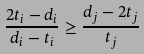<formula> <loc_0><loc_0><loc_500><loc_500>\frac { 2 t _ { i } - d _ { i } } { d _ { i } - t _ { i } } \geq \frac { d _ { j } - 2 t _ { j } } { t _ { j } }</formula> 